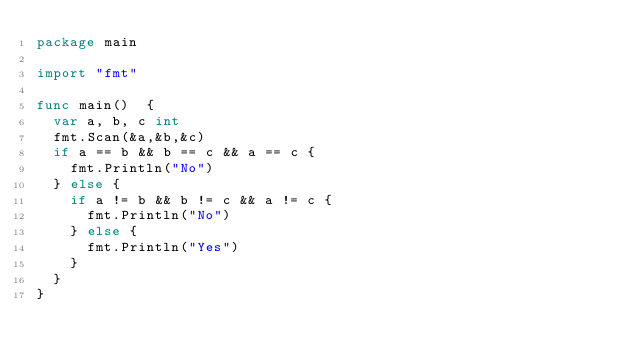<code> <loc_0><loc_0><loc_500><loc_500><_Go_>package main

import "fmt"

func main()  {
	var a, b, c int
	fmt.Scan(&a,&b,&c)
	if a == b && b == c && a == c {
		fmt.Println("No")
	} else {
		if a != b && b != c && a != c {
			fmt.Println("No")
		} else {
			fmt.Println("Yes")
		}
	}
}</code> 